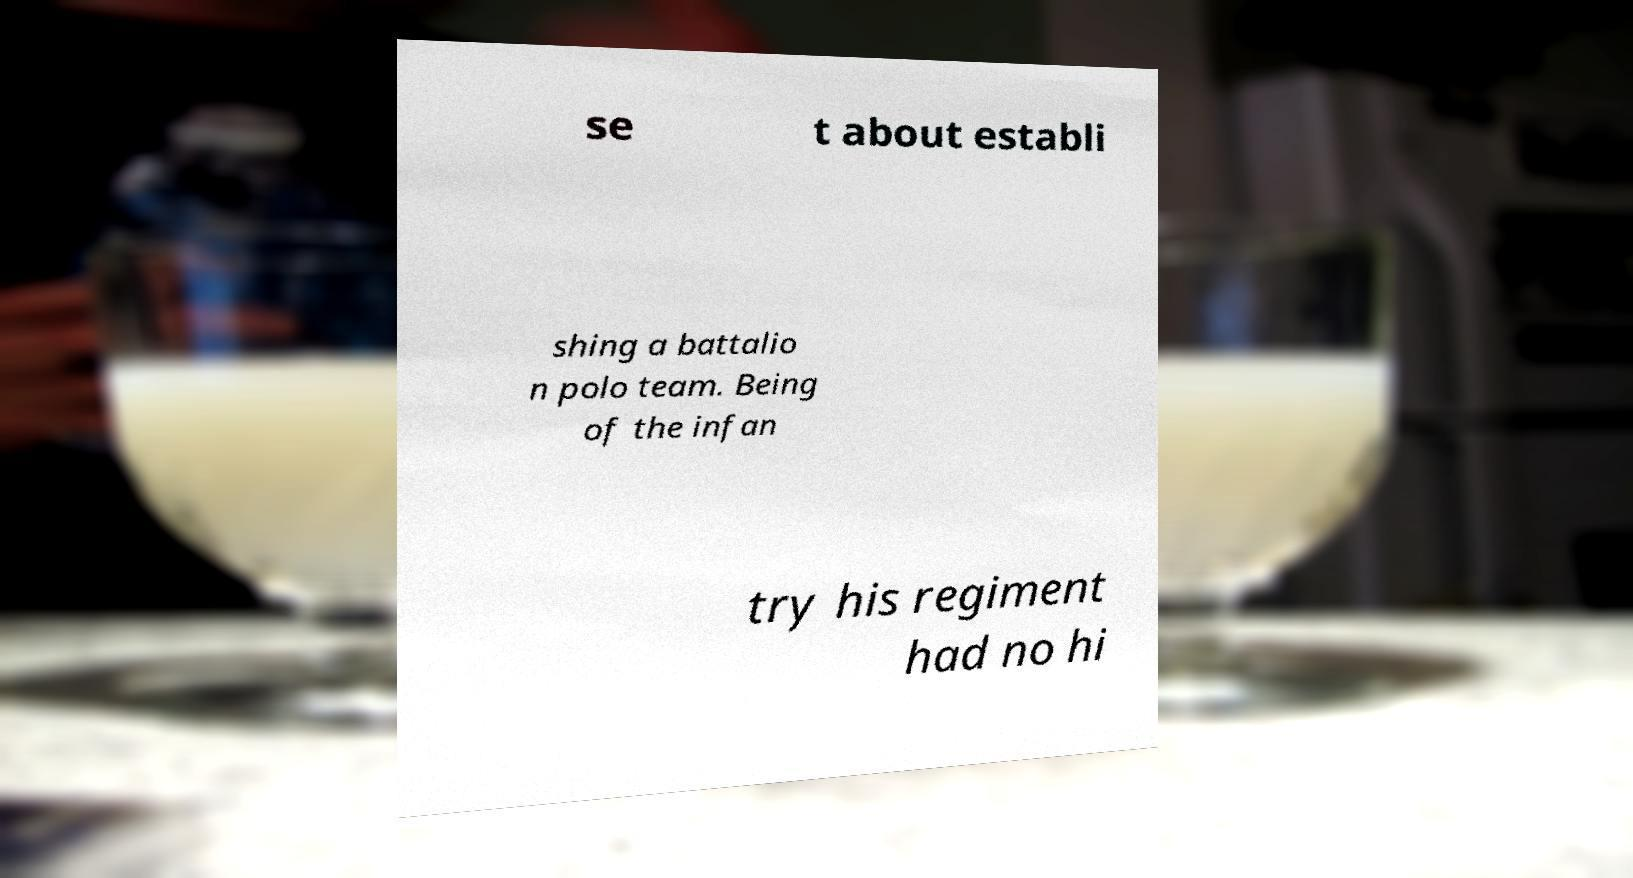I need the written content from this picture converted into text. Can you do that? se t about establi shing a battalio n polo team. Being of the infan try his regiment had no hi 